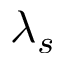Convert formula to latex. <formula><loc_0><loc_0><loc_500><loc_500>\lambda _ { s }</formula> 